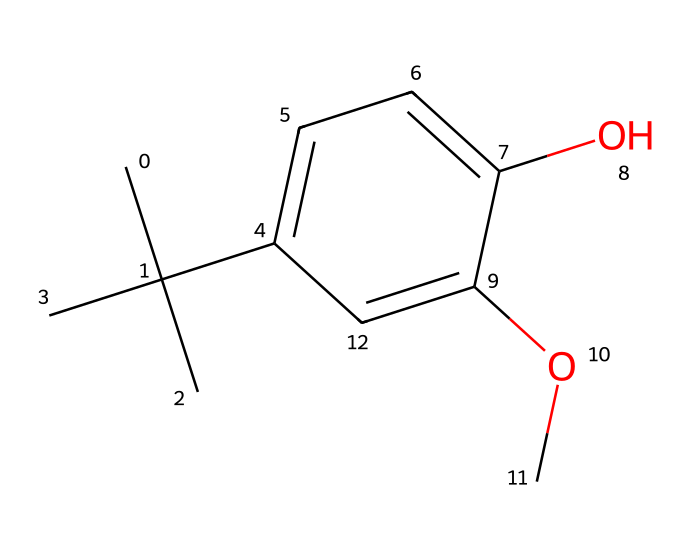How many carbon atoms are present in BHA? By analyzing the SMILES representation, we can count the number of carbon atoms. The notation 'CC(C)(C)' indicates three methyl groups along with a carbon atom in the aromatic ring, totaling to 9 carbon atoms in the entire structure.
Answer: 9 What functional groups are present in BHA? Upon examining the chemical structure, we can identify a hydroxyl group (-OH) attached to the aromatic ring and a methoxy group (-OCH3), making these the two functional groups in BHA.
Answer: hydroxyl and methoxy How many hydrogen atoms are attached to the molecule? We can determine the number of hydrogen atoms by examining the bonding of the carbon atoms. Each carbon in aliphatic chains tends to bond to two or three hydrogen atoms, and the carbons in the aromatic ring will typically bond to one hydrogen each. Each functional group also contributes hydrogen. In total, there are 12 hydrogen atoms.
Answer: 12 What type of reaction is BHA commonly used in? BHA is primarily used as an antioxidant in food preservation. This means it reacts with free radicals to prevent oxidation and spoilage. The presence of hydroxyl groups contributes to this antioxidant activity.
Answer: antioxidant Why is BHA considered a preservative? BHA is classified as a preservative due to its ability to inhibit the oxidation of fats and oils, which can lead to rancidity in food products. This is largely due to its structure which provides stability against oxidative degradation.
Answer: inhibits oxidation 